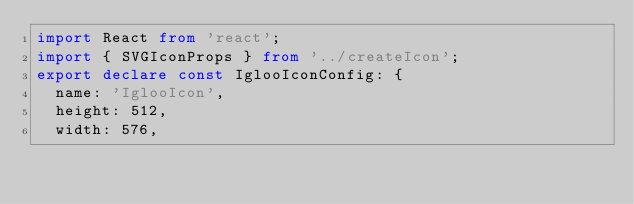<code> <loc_0><loc_0><loc_500><loc_500><_TypeScript_>import React from 'react';
import { SVGIconProps } from '../createIcon';
export declare const IglooIconConfig: {
  name: 'IglooIcon',
  height: 512,
  width: 576,</code> 